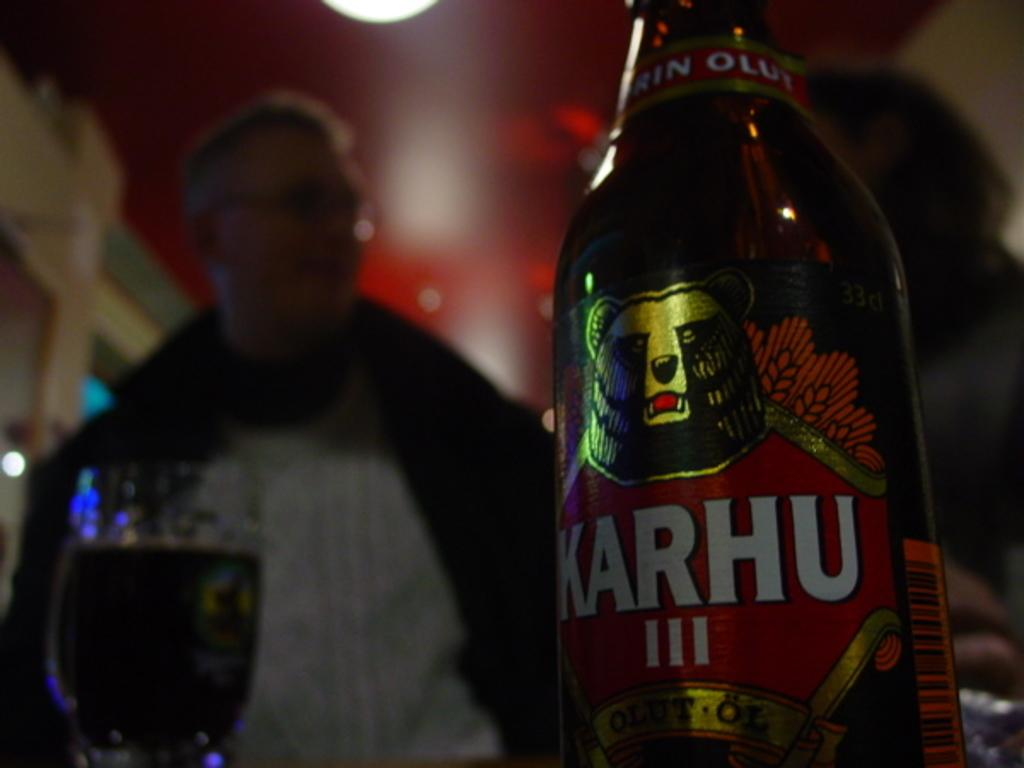Provide a one-sentence caption for the provided image. A couple enjoying a night out in a pub with Karhu beer sitting on the table. 